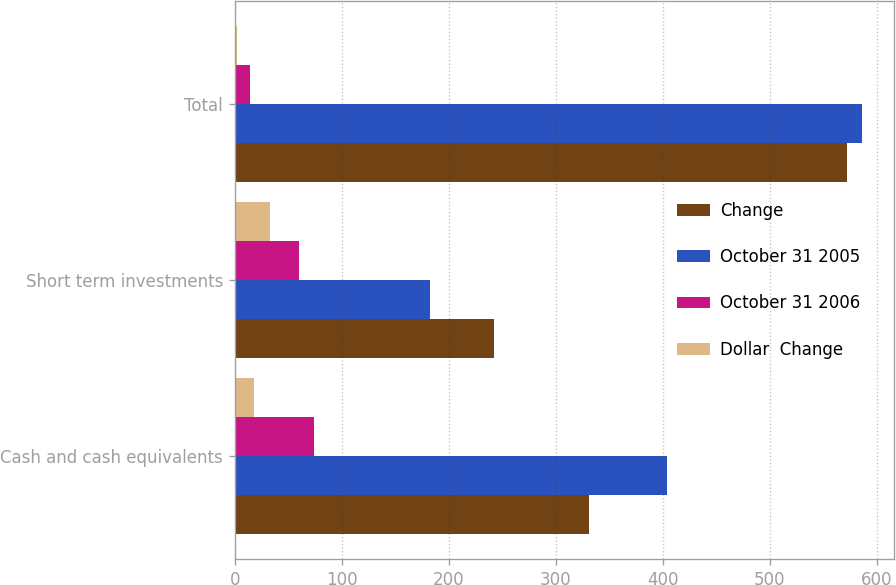<chart> <loc_0><loc_0><loc_500><loc_500><stacked_bar_chart><ecel><fcel>Cash and cash equivalents<fcel>Short term investments<fcel>Total<nl><fcel>Change<fcel>330.7<fcel>242<fcel>572.7<nl><fcel>October 31 2005<fcel>404.4<fcel>182.1<fcel>586.5<nl><fcel>October 31 2006<fcel>73.7<fcel>59.9<fcel>13.8<nl><fcel>Dollar  Change<fcel>18<fcel>33<fcel>2<nl></chart> 